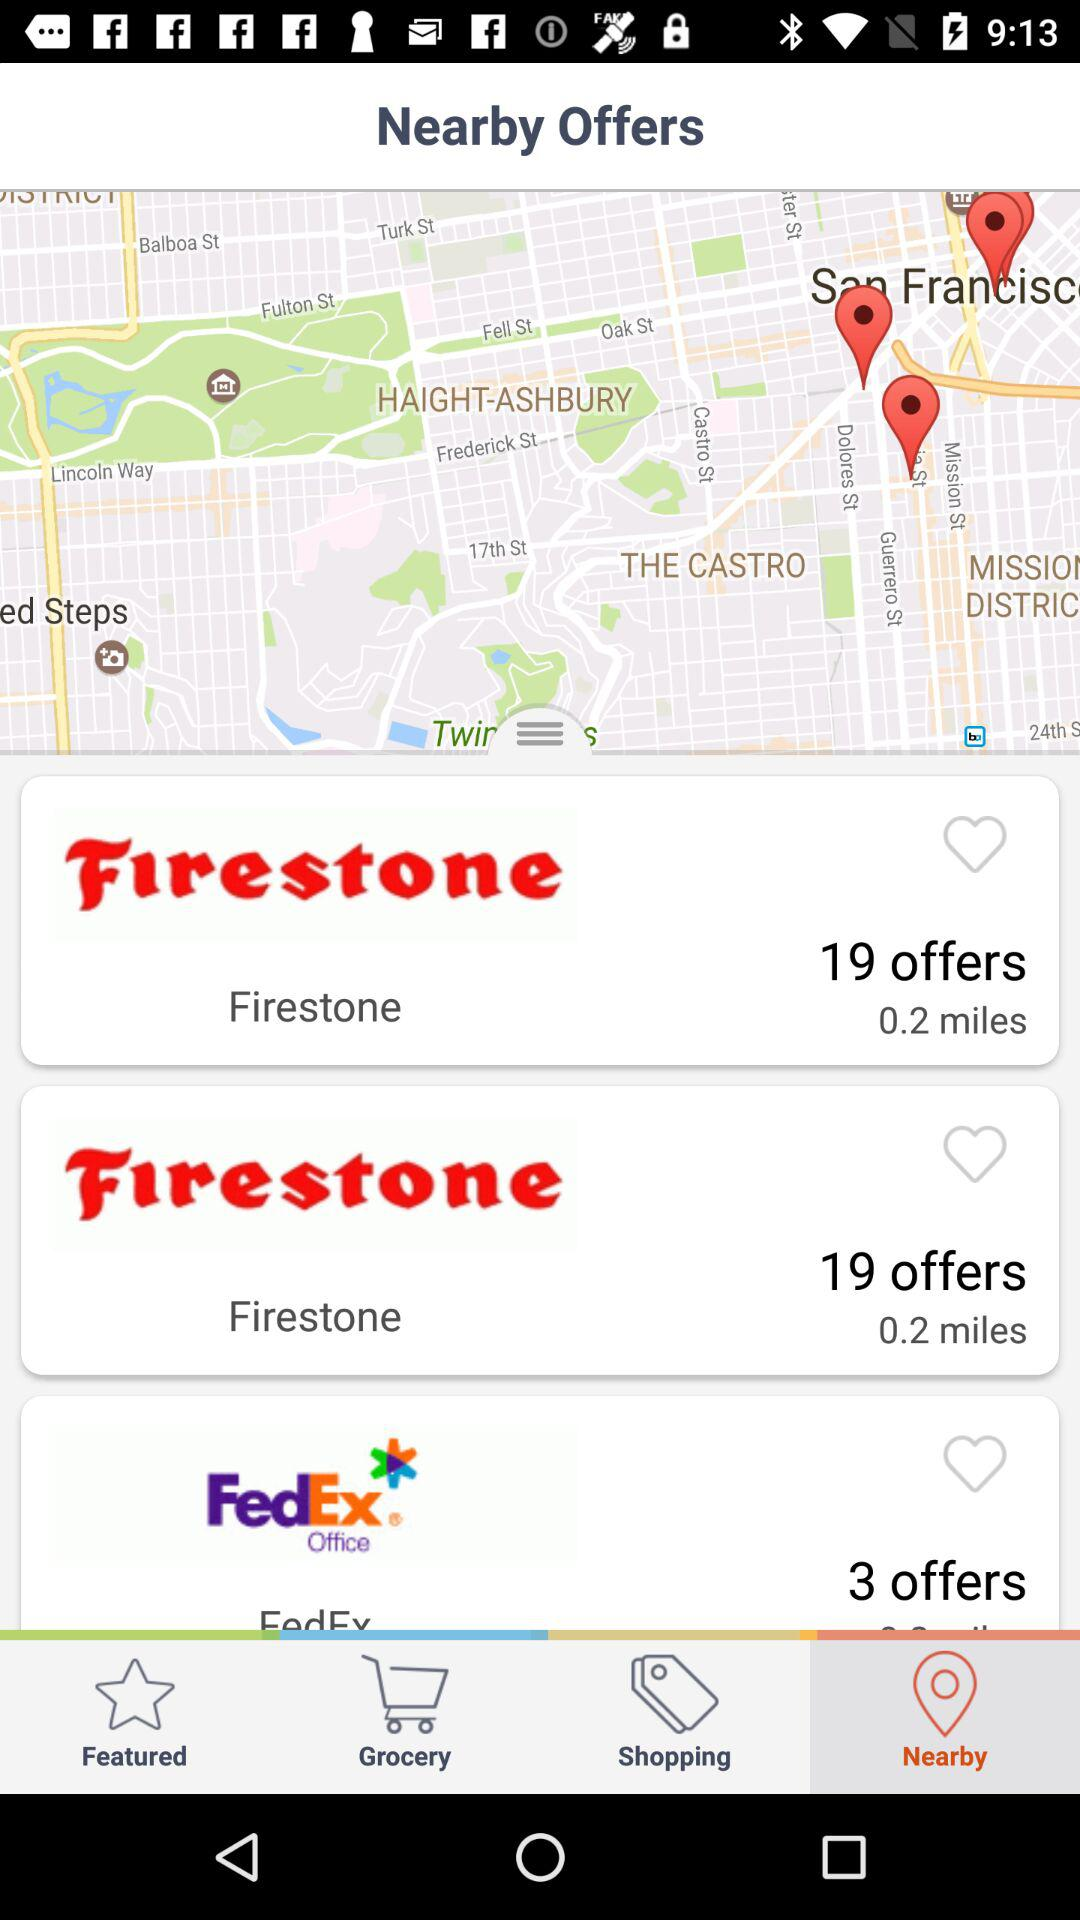Which tab is currently selected? The currently selected tab is "Nearby". 